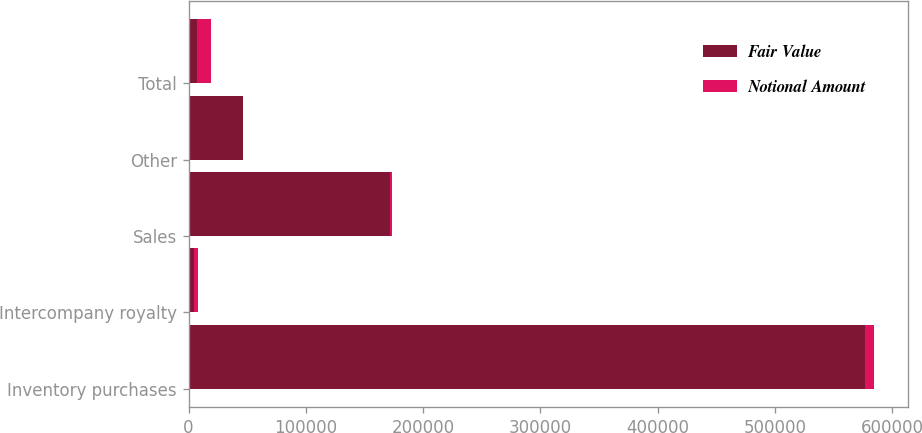Convert chart. <chart><loc_0><loc_0><loc_500><loc_500><stacked_bar_chart><ecel><fcel>Inventory purchases<fcel>Intercompany royalty<fcel>Sales<fcel>Other<fcel>Total<nl><fcel>Fair Value<fcel>577138<fcel>4948<fcel>171393<fcel>46563<fcel>7493<nl><fcel>Notional Amount<fcel>7493<fcel>2774<fcel>1965<fcel>302<fcel>11930<nl></chart> 